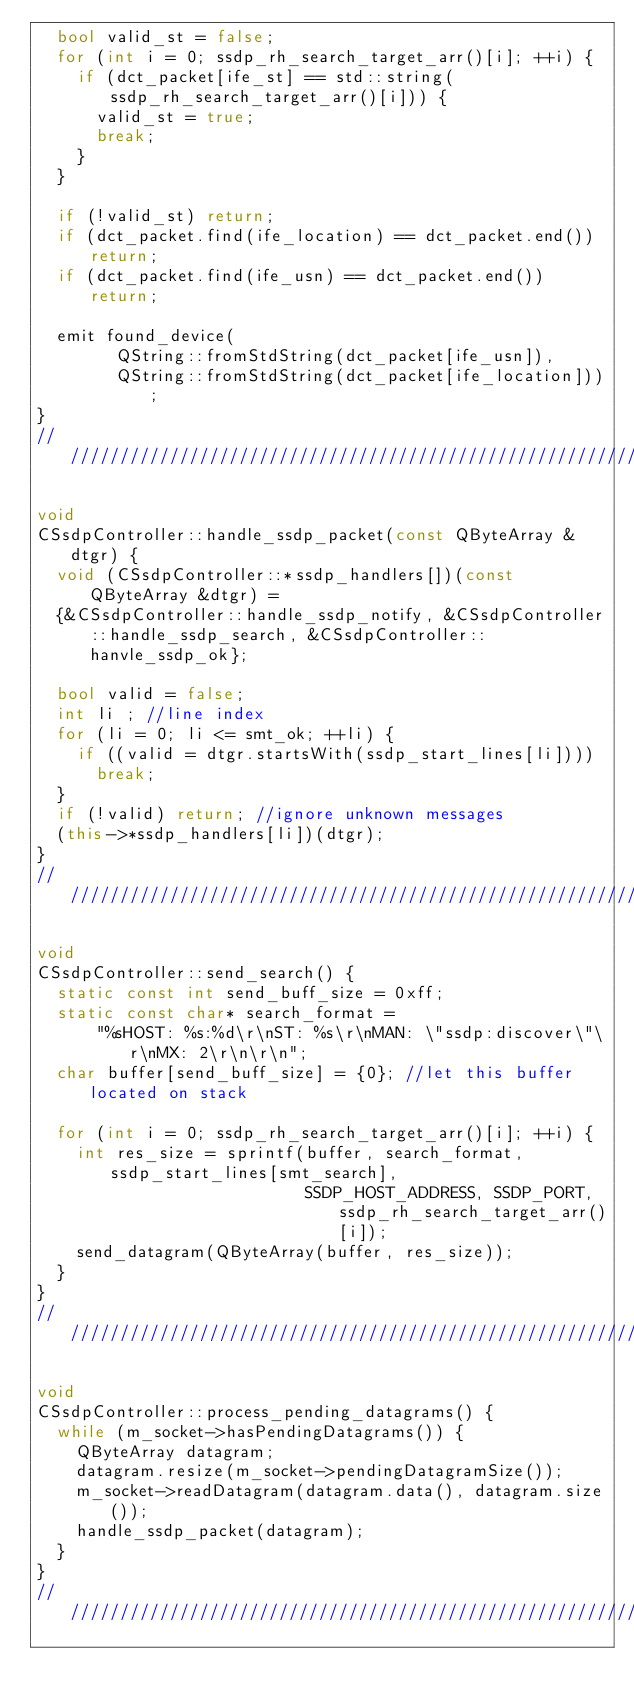Convert code to text. <code><loc_0><loc_0><loc_500><loc_500><_C++_>  bool valid_st = false;
  for (int i = 0; ssdp_rh_search_target_arr()[i]; ++i) {
    if (dct_packet[ife_st] == std::string(ssdp_rh_search_target_arr()[i])) {
      valid_st = true;
      break;
    }
  }

  if (!valid_st) return;
  if (dct_packet.find(ife_location) == dct_packet.end()) return;
  if (dct_packet.find(ife_usn) == dct_packet.end()) return;

  emit found_device(
        QString::fromStdString(dct_packet[ife_usn]),
        QString::fromStdString(dct_packet[ife_location]));
}
////////////////////////////////////////////////////////////////////////////

void
CSsdpController::handle_ssdp_packet(const QByteArray &dtgr) {
  void (CSsdpController::*ssdp_handlers[])(const QByteArray &dtgr) =
  {&CSsdpController::handle_ssdp_notify, &CSsdpController::handle_ssdp_search, &CSsdpController::hanvle_ssdp_ok};

  bool valid = false;
  int li ; //line index
  for (li = 0; li <= smt_ok; ++li) {
    if ((valid = dtgr.startsWith(ssdp_start_lines[li])))
      break;
  }
  if (!valid) return; //ignore unknown messages
  (this->*ssdp_handlers[li])(dtgr);
}
////////////////////////////////////////////////////////////////////////////

void
CSsdpController::send_search() {
  static const int send_buff_size = 0xff;
  static const char* search_format =
      "%sHOST: %s:%d\r\nST: %s\r\nMAN: \"ssdp:discover\"\r\nMX: 2\r\n\r\n";
  char buffer[send_buff_size] = {0}; //let this buffer located on stack

  for (int i = 0; ssdp_rh_search_target_arr()[i]; ++i) {
    int res_size = sprintf(buffer, search_format, ssdp_start_lines[smt_search],
                           SSDP_HOST_ADDRESS, SSDP_PORT, ssdp_rh_search_target_arr()[i]);
    send_datagram(QByteArray(buffer, res_size));
  }
}
////////////////////////////////////////////////////////////////////////////

void
CSsdpController::process_pending_datagrams() {
  while (m_socket->hasPendingDatagrams()) {
    QByteArray datagram;
    datagram.resize(m_socket->pendingDatagramSize());
    m_socket->readDatagram(datagram.data(), datagram.size());
    handle_ssdp_packet(datagram);
  }
}
////////////////////////////////////////////////////////////////////////////
</code> 